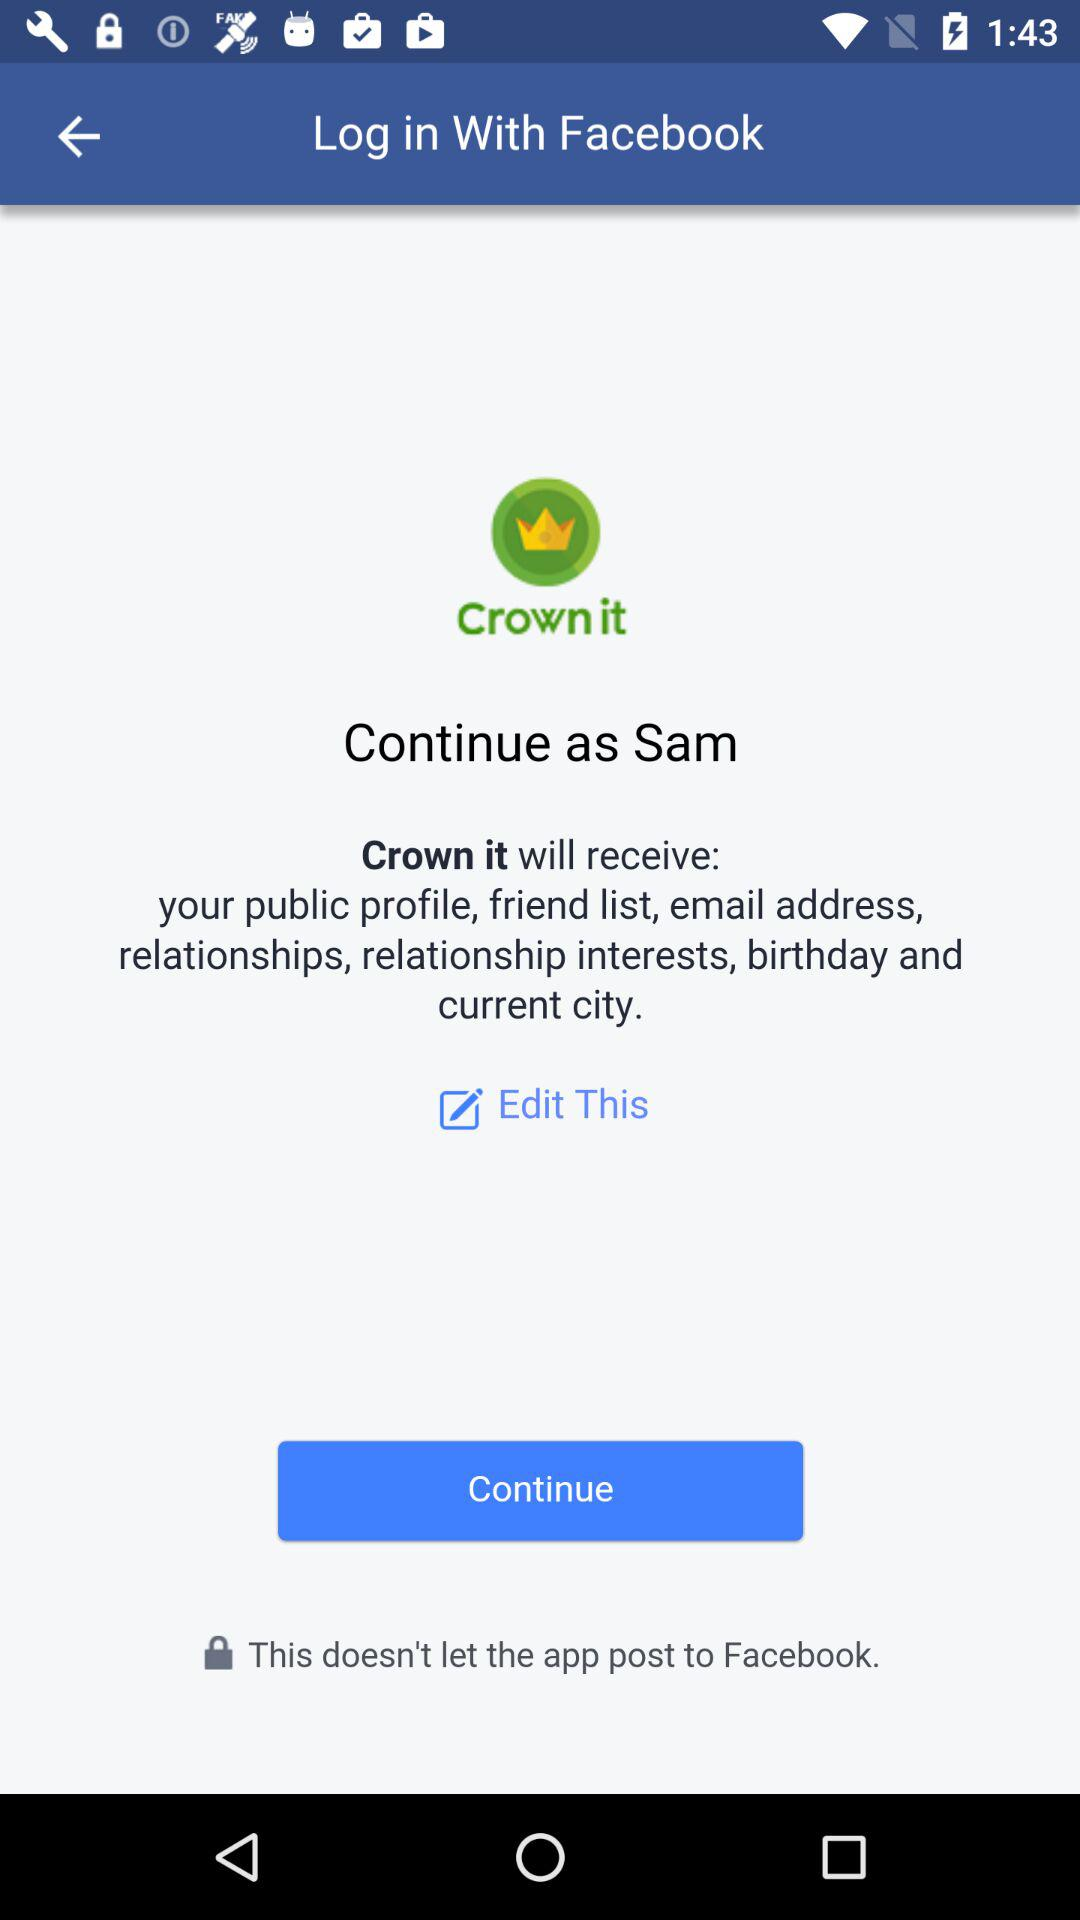What is the user name? The user name is Sam. 